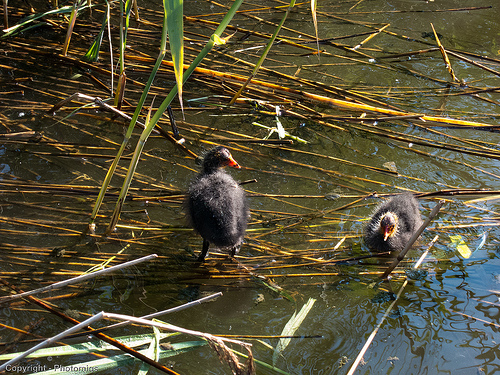<image>
Is there a duck next to the duck? Yes. The duck is positioned adjacent to the duck, located nearby in the same general area. Is the duck to the left of the duck? Yes. From this viewpoint, the duck is positioned to the left side relative to the duck. 